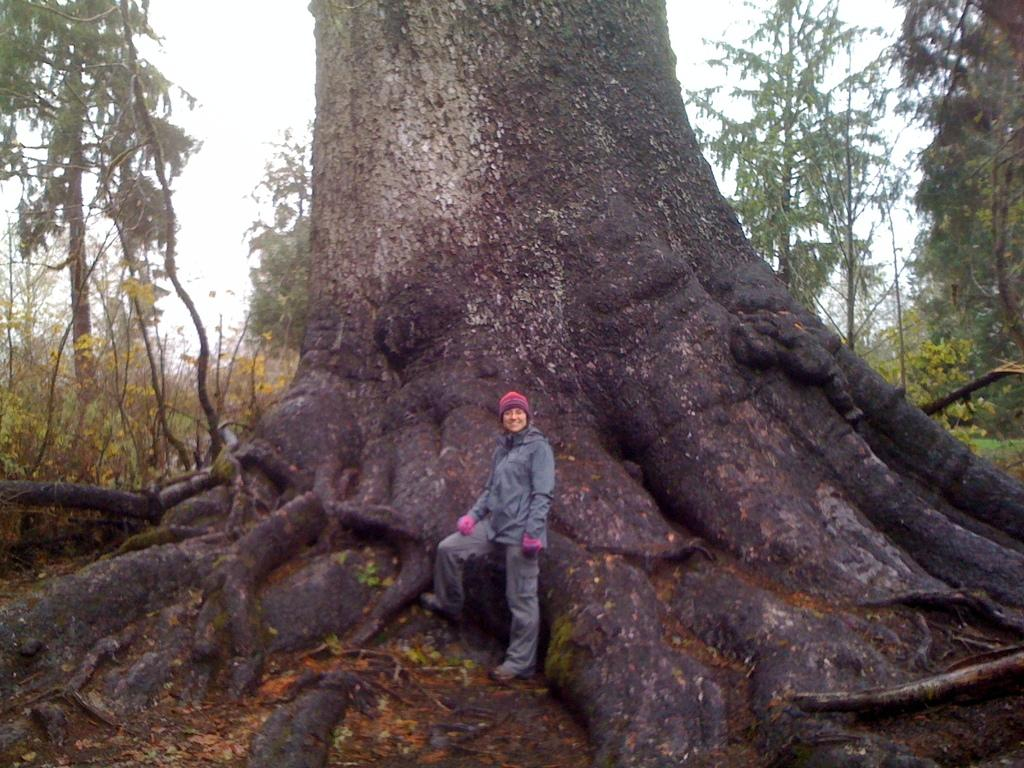Who or what is present in the image? There is a person in the image. What is the person doing in the image? The person is standing and smiling. What type of natural environment can be seen in the image? There are trees in the image, and the sky is visible in the background. What type of sheet is being used to cut the leaf in the image? There is no sheet or leaf present in the image; it features a person standing and smiling. 